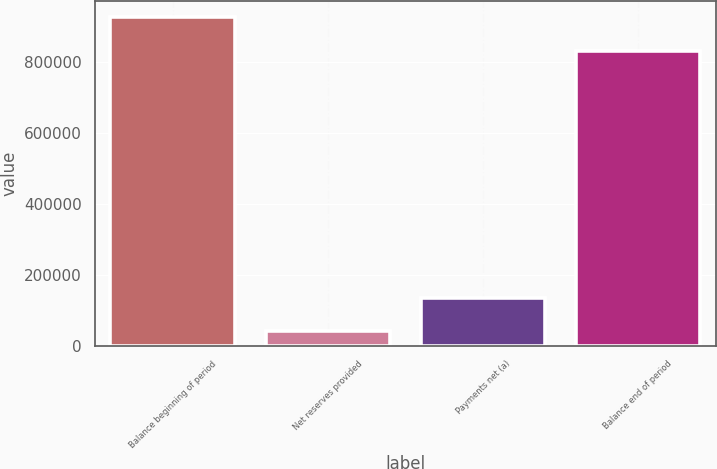Convert chart. <chart><loc_0><loc_0><loc_500><loc_500><bar_chart><fcel>Balance beginning of period<fcel>Net reserves provided<fcel>Payments net (a)<fcel>Balance end of period<nl><fcel>924563<fcel>40784<fcel>134289<fcel>831058<nl></chart> 